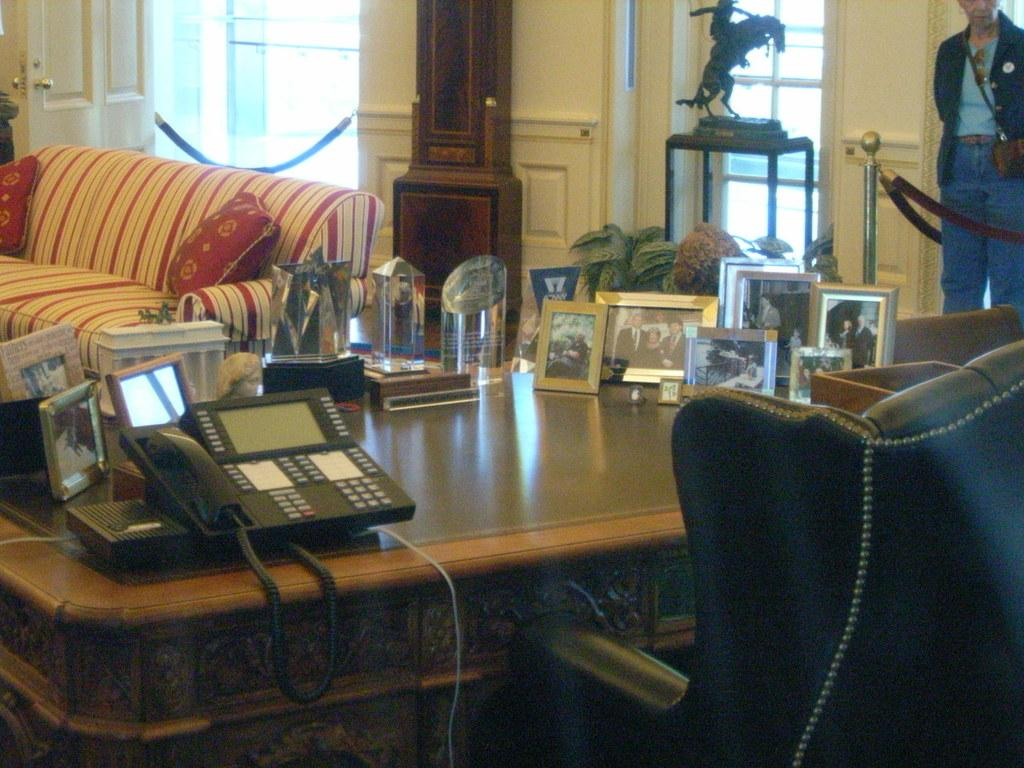What is the main subject in the image? There is a person standing in the image. What type of furniture is present in the image? There is a sofa and a table in the image. What decorative item can be seen in the image? There is a photo frame in the image. What type of communication device is present in the image? There is a telephone in the image. How many cherries are on the table in the image? There are no cherries present in the image. What type of pain is the person experiencing in the image? There is no indication of pain or any physical discomfort in the image. 